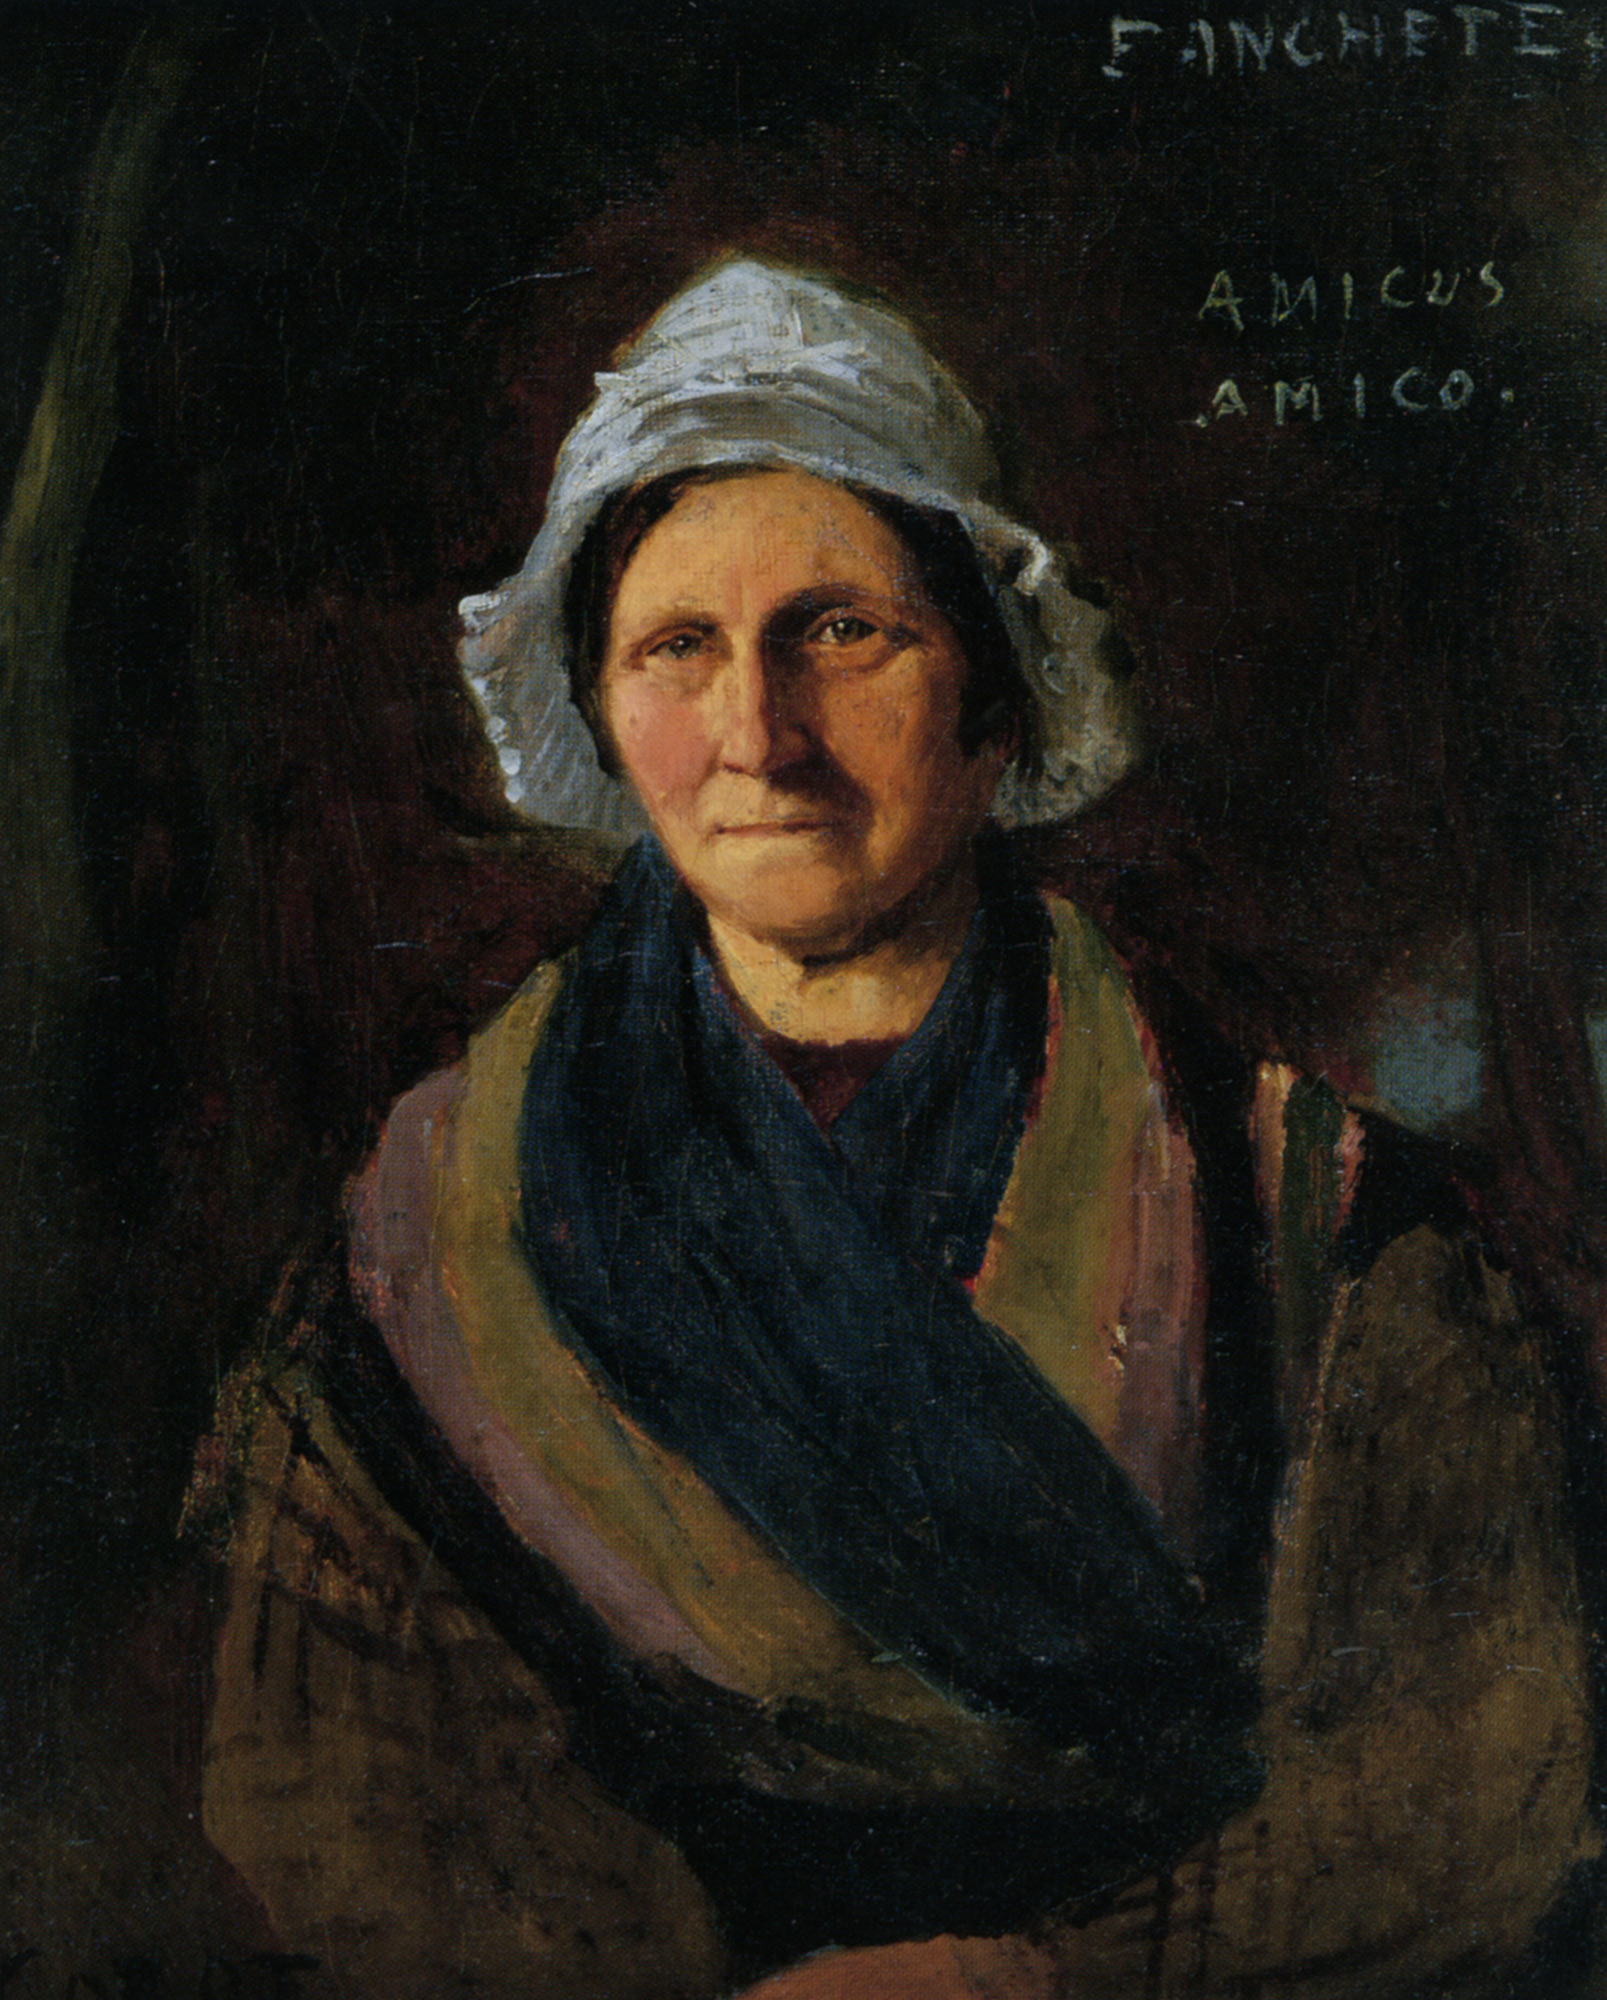Can you elaborate on the elements of the picture provided? The image is a captivating oil painting featuring a woman rendered in a detailed and realistic style. She wears a white bonnet and a blue shawl, which contrasts strikingly against the dark background, making her the focal point of the painting. The dark hues surrounding her emphasize the lighter tones of her clothing, drawing the viewer's attention directly to her. In the top right corner, the painting is signed 'FINCHETE' and features the inscription 'AMICUS AMICO,' perhaps hinting at the artist's name or conveying a thoughtful message. The overall mastery of this artwork is evident through the meticulous attention to detail in the depiction of the woman's features, suggesting a high level of skill and precision by the artist. This portrayal not only captures her physical appearance but also provides a glimpse into her character and the epoch she represents, making it a profound representation of portraiture. 